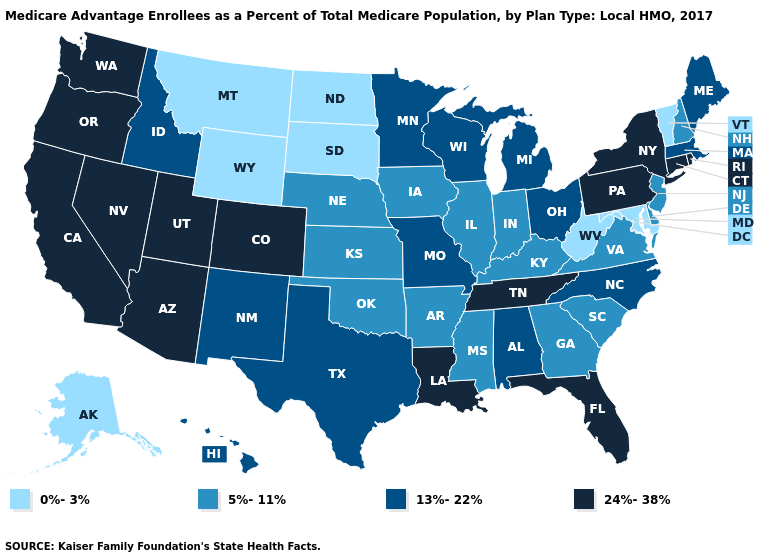Which states have the lowest value in the West?
Concise answer only. Alaska, Montana, Wyoming. What is the highest value in the MidWest ?
Short answer required. 13%-22%. What is the value of Mississippi?
Answer briefly. 5%-11%. Name the states that have a value in the range 13%-22%?
Be succinct. Alabama, Hawaii, Idaho, Massachusetts, Maine, Michigan, Minnesota, Missouri, North Carolina, New Mexico, Ohio, Texas, Wisconsin. Does Indiana have a lower value than Vermont?
Be succinct. No. What is the lowest value in states that border Idaho?
Quick response, please. 0%-3%. Which states have the highest value in the USA?
Write a very short answer. Arizona, California, Colorado, Connecticut, Florida, Louisiana, Nevada, New York, Oregon, Pennsylvania, Rhode Island, Tennessee, Utah, Washington. Does Wisconsin have a lower value than Rhode Island?
Concise answer only. Yes. Does Rhode Island have the highest value in the Northeast?
Answer briefly. Yes. Does New York have the highest value in the Northeast?
Write a very short answer. Yes. Is the legend a continuous bar?
Give a very brief answer. No. Name the states that have a value in the range 5%-11%?
Answer briefly. Arkansas, Delaware, Georgia, Iowa, Illinois, Indiana, Kansas, Kentucky, Mississippi, Nebraska, New Hampshire, New Jersey, Oklahoma, South Carolina, Virginia. What is the lowest value in states that border Michigan?
Short answer required. 5%-11%. What is the lowest value in the USA?
Write a very short answer. 0%-3%. Does Hawaii have the highest value in the USA?
Write a very short answer. No. 